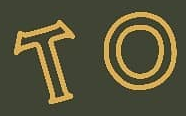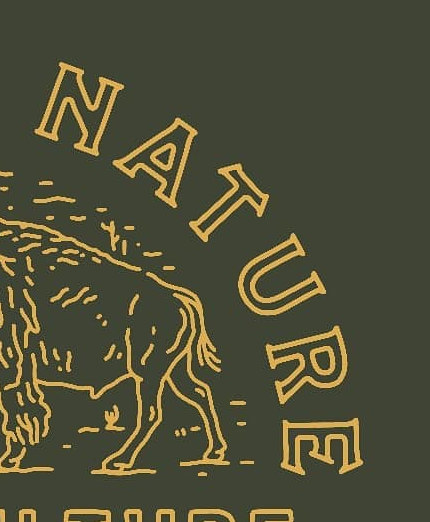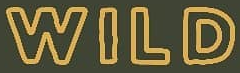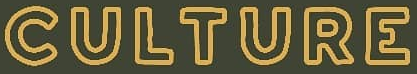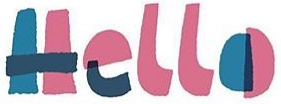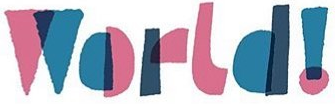Read the text content from these images in order, separated by a semicolon. TO; NATURE; WILD; CULTURE; Hello; World! 